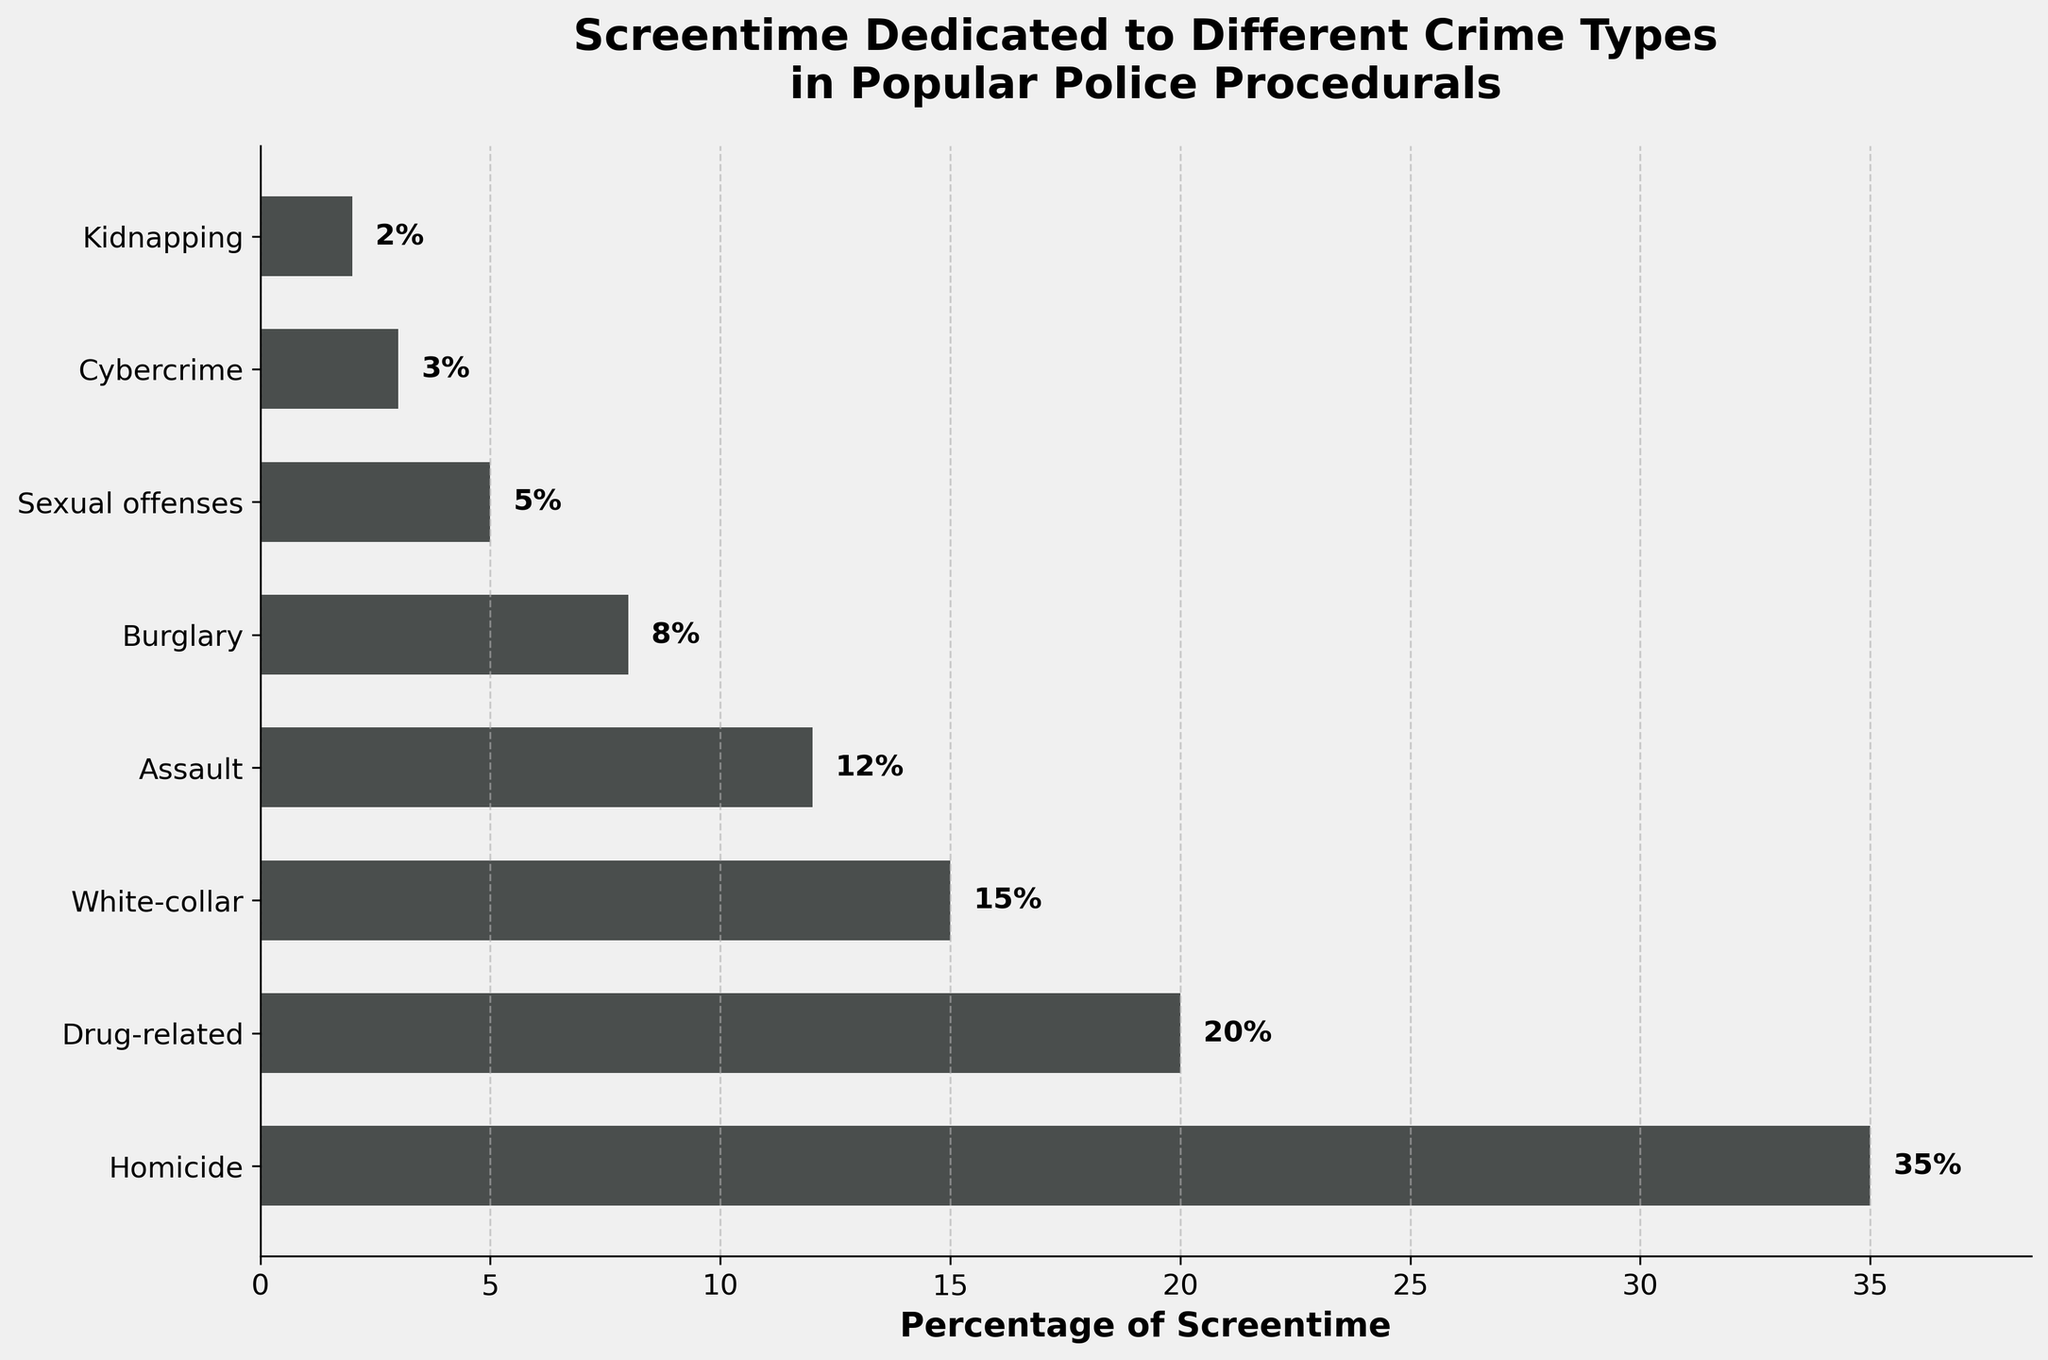Which crime type has the highest percentage of screentime? The figure shows that 'Homicide' has the longest bar, indicating the highest percentage.
Answer: Homicide How much more screentime is dedicated to drug-related crimes compared to cybercrime? The screentime for drug-related crimes is 20%, and for cybercrime, it's 3%. Subtract 3 from 20 to find the difference.
Answer: 17% What is the combined percentage of screentime for white-collar crime and burglary? The screentime for white-collar crime is 15% and for burglary, it’s 8%. Add these percentages together.
Answer: 23% Which crime type has the least screentime, and what is that percentage? The figure shows that 'Kidnapping' has the shortest bar, indicating the least percentage.
Answer: Kidnapping, 2% How does the total screentime of sexual offenses and cybercrime compare to that of drug-related crime? Sexual offenses have 5%, and cybercrime has 3%, so combined they have 8%. Drug-related crime has 20%. The combined screentime of sexual offenses and cybercrime is less.
Answer: Less (8% vs 20%) Which crime types have more screentime than assault? The figure shows that 'Homicide', 'Drug-related', and 'White-collar' all have percentages higher than 12% (the screentime for assault).
Answer: Homicide, Drug-related, White-collar What is the average screentime percentage for the crime types shown? Add all percentages: 35 + 20 + 15 + 12 + 8 + 5 + 3 + 2 = 100. Divide by the number of crime types, which is 8.
Answer: 12.5% Are there any crime types whose combined screentime equals that of homicide? Homicide has 35%. Adding diverse combinations of the other crime types does not sum exactly to 35%.
Answer: No What percentage of screentime is dedicated to crimes that are not drug-related or homicide? Subtract the percentages for drug-related (20%) and homicide (35%) from the total (100%). 100 - 20 - 35 = 45%.
Answer: 45% What is the difference in screentime between the highest and lowest crime type categories? The highest crime type (Homicide) is 35%, and the lowest (Kidnapping) is 2%. Subtract 2 from 35.
Answer: 33% 